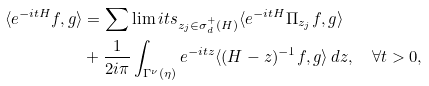<formula> <loc_0><loc_0><loc_500><loc_500>\langle e ^ { - i t H } f , g \rangle & = \sum \lim i t s _ { z _ { j } \in \sigma _ { d } ^ { + } ( H ) } \langle e ^ { - i t H } \Pi _ { z _ { j } } f , g \rangle \\ & + \frac { 1 } { 2 i \pi } \int _ { \Gamma ^ { \nu } ( \eta ) } e ^ { - i t z } \langle ( H - z ) ^ { - 1 } f , g \rangle \, d z , \quad \forall t > 0 ,</formula> 